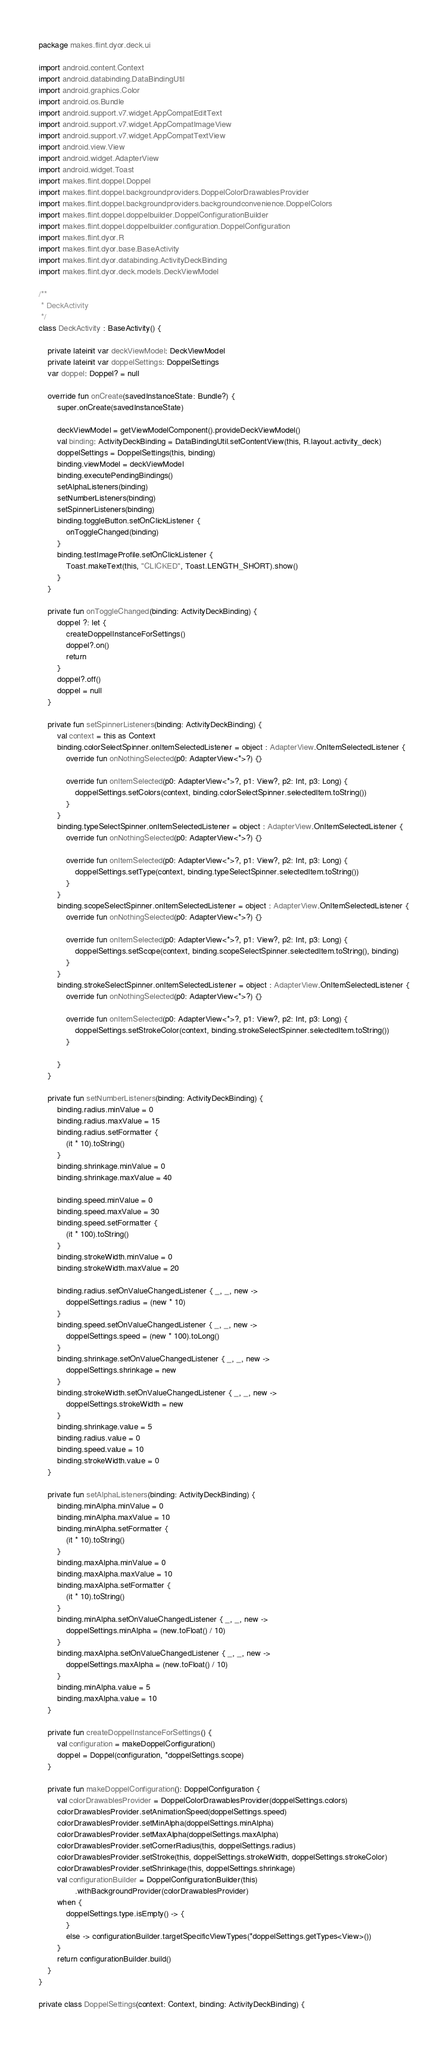Convert code to text. <code><loc_0><loc_0><loc_500><loc_500><_Kotlin_>package makes.flint.dyor.deck.ui

import android.content.Context
import android.databinding.DataBindingUtil
import android.graphics.Color
import android.os.Bundle
import android.support.v7.widget.AppCompatEditText
import android.support.v7.widget.AppCompatImageView
import android.support.v7.widget.AppCompatTextView
import android.view.View
import android.widget.AdapterView
import android.widget.Toast
import makes.flint.doppel.Doppel
import makes.flint.doppel.backgroundproviders.DoppelColorDrawablesProvider
import makes.flint.doppel.backgroundproviders.backgroundconvenience.DoppelColors
import makes.flint.doppel.doppelbuilder.DoppelConfigurationBuilder
import makes.flint.doppel.doppelbuilder.configuration.DoppelConfiguration
import makes.flint.dyor.R
import makes.flint.dyor.base.BaseActivity
import makes.flint.dyor.databinding.ActivityDeckBinding
import makes.flint.dyor.deck.models.DeckViewModel

/**
 * DeckActivity
 */
class DeckActivity : BaseActivity() {

    private lateinit var deckViewModel: DeckViewModel
    private lateinit var doppelSettings: DoppelSettings
    var doppel: Doppel? = null

    override fun onCreate(savedInstanceState: Bundle?) {
        super.onCreate(savedInstanceState)

        deckViewModel = getViewModelComponent().provideDeckViewModel()
        val binding: ActivityDeckBinding = DataBindingUtil.setContentView(this, R.layout.activity_deck)
        doppelSettings = DoppelSettings(this, binding)
        binding.viewModel = deckViewModel
        binding.executePendingBindings()
        setAlphaListeners(binding)
        setNumberListeners(binding)
        setSpinnerListeners(binding)
        binding.toggleButton.setOnClickListener {
            onToggleChanged(binding)
        }
        binding.testImageProfile.setOnClickListener {
            Toast.makeText(this, "CLICKED", Toast.LENGTH_SHORT).show()
        }
    }

    private fun onToggleChanged(binding: ActivityDeckBinding) {
        doppel ?: let {
            createDoppelInstanceForSettings()
            doppel?.on()
            return
        }
        doppel?.off()
        doppel = null
    }

    private fun setSpinnerListeners(binding: ActivityDeckBinding) {
        val context = this as Context
        binding.colorSelectSpinner.onItemSelectedListener = object : AdapterView.OnItemSelectedListener {
            override fun onNothingSelected(p0: AdapterView<*>?) {}

            override fun onItemSelected(p0: AdapterView<*>?, p1: View?, p2: Int, p3: Long) {
                doppelSettings.setColors(context, binding.colorSelectSpinner.selectedItem.toString())
            }
        }
        binding.typeSelectSpinner.onItemSelectedListener = object : AdapterView.OnItemSelectedListener {
            override fun onNothingSelected(p0: AdapterView<*>?) {}

            override fun onItemSelected(p0: AdapterView<*>?, p1: View?, p2: Int, p3: Long) {
                doppelSettings.setType(context, binding.typeSelectSpinner.selectedItem.toString())
            }
        }
        binding.scopeSelectSpinner.onItemSelectedListener = object : AdapterView.OnItemSelectedListener {
            override fun onNothingSelected(p0: AdapterView<*>?) {}

            override fun onItemSelected(p0: AdapterView<*>?, p1: View?, p2: Int, p3: Long) {
                doppelSettings.setScope(context, binding.scopeSelectSpinner.selectedItem.toString(), binding)
            }
        }
        binding.strokeSelectSpinner.onItemSelectedListener = object : AdapterView.OnItemSelectedListener {
            override fun onNothingSelected(p0: AdapterView<*>?) {}

            override fun onItemSelected(p0: AdapterView<*>?, p1: View?, p2: Int, p3: Long) {
                doppelSettings.setStrokeColor(context, binding.strokeSelectSpinner.selectedItem.toString())
            }

        }
    }

    private fun setNumberListeners(binding: ActivityDeckBinding) {
        binding.radius.minValue = 0
        binding.radius.maxValue = 15
        binding.radius.setFormatter {
            (it * 10).toString()
        }
        binding.shrinkage.minValue = 0
        binding.shrinkage.maxValue = 40

        binding.speed.minValue = 0
        binding.speed.maxValue = 30
        binding.speed.setFormatter {
            (it * 100).toString()
        }
        binding.strokeWidth.minValue = 0
        binding.strokeWidth.maxValue = 20

        binding.radius.setOnValueChangedListener { _, _, new ->
            doppelSettings.radius = (new * 10)
        }
        binding.speed.setOnValueChangedListener { _, _, new ->
            doppelSettings.speed = (new * 100).toLong()
        }
        binding.shrinkage.setOnValueChangedListener { _, _, new ->
            doppelSettings.shrinkage = new
        }
        binding.strokeWidth.setOnValueChangedListener { _, _, new ->
            doppelSettings.strokeWidth = new
        }
        binding.shrinkage.value = 5
        binding.radius.value = 0
        binding.speed.value = 10
        binding.strokeWidth.value = 0
    }

    private fun setAlphaListeners(binding: ActivityDeckBinding) {
        binding.minAlpha.minValue = 0
        binding.minAlpha.maxValue = 10
        binding.minAlpha.setFormatter {
            (it * 10).toString()
        }
        binding.maxAlpha.minValue = 0
        binding.maxAlpha.maxValue = 10
        binding.maxAlpha.setFormatter {
            (it * 10).toString()
        }
        binding.minAlpha.setOnValueChangedListener { _, _, new ->
            doppelSettings.minAlpha = (new.toFloat() / 10)
        }
        binding.maxAlpha.setOnValueChangedListener { _, _, new ->
            doppelSettings.maxAlpha = (new.toFloat() / 10)
        }
        binding.minAlpha.value = 5
        binding.maxAlpha.value = 10
    }

    private fun createDoppelInstanceForSettings() {
        val configuration = makeDoppelConfiguration()
        doppel = Doppel(configuration, *doppelSettings.scope)
    }

    private fun makeDoppelConfiguration(): DoppelConfiguration {
        val colorDrawablesProvider = DoppelColorDrawablesProvider(doppelSettings.colors)
        colorDrawablesProvider.setAnimationSpeed(doppelSettings.speed)
        colorDrawablesProvider.setMinAlpha(doppelSettings.minAlpha)
        colorDrawablesProvider.setMaxAlpha(doppelSettings.maxAlpha)
        colorDrawablesProvider.setCornerRadius(this, doppelSettings.radius)
        colorDrawablesProvider.setStroke(this, doppelSettings.strokeWidth, doppelSettings.strokeColor)
        colorDrawablesProvider.setShrinkage(this, doppelSettings.shrinkage)
        val configurationBuilder = DoppelConfigurationBuilder(this)
                .withBackgroundProvider(colorDrawablesProvider)
        when {
            doppelSettings.type.isEmpty() -> {
            }
            else -> configurationBuilder.targetSpecificViewTypes(*doppelSettings.getTypes<View>())
        }
        return configurationBuilder.build()
    }
}

private class DoppelSettings(context: Context, binding: ActivityDeckBinding) {
</code> 